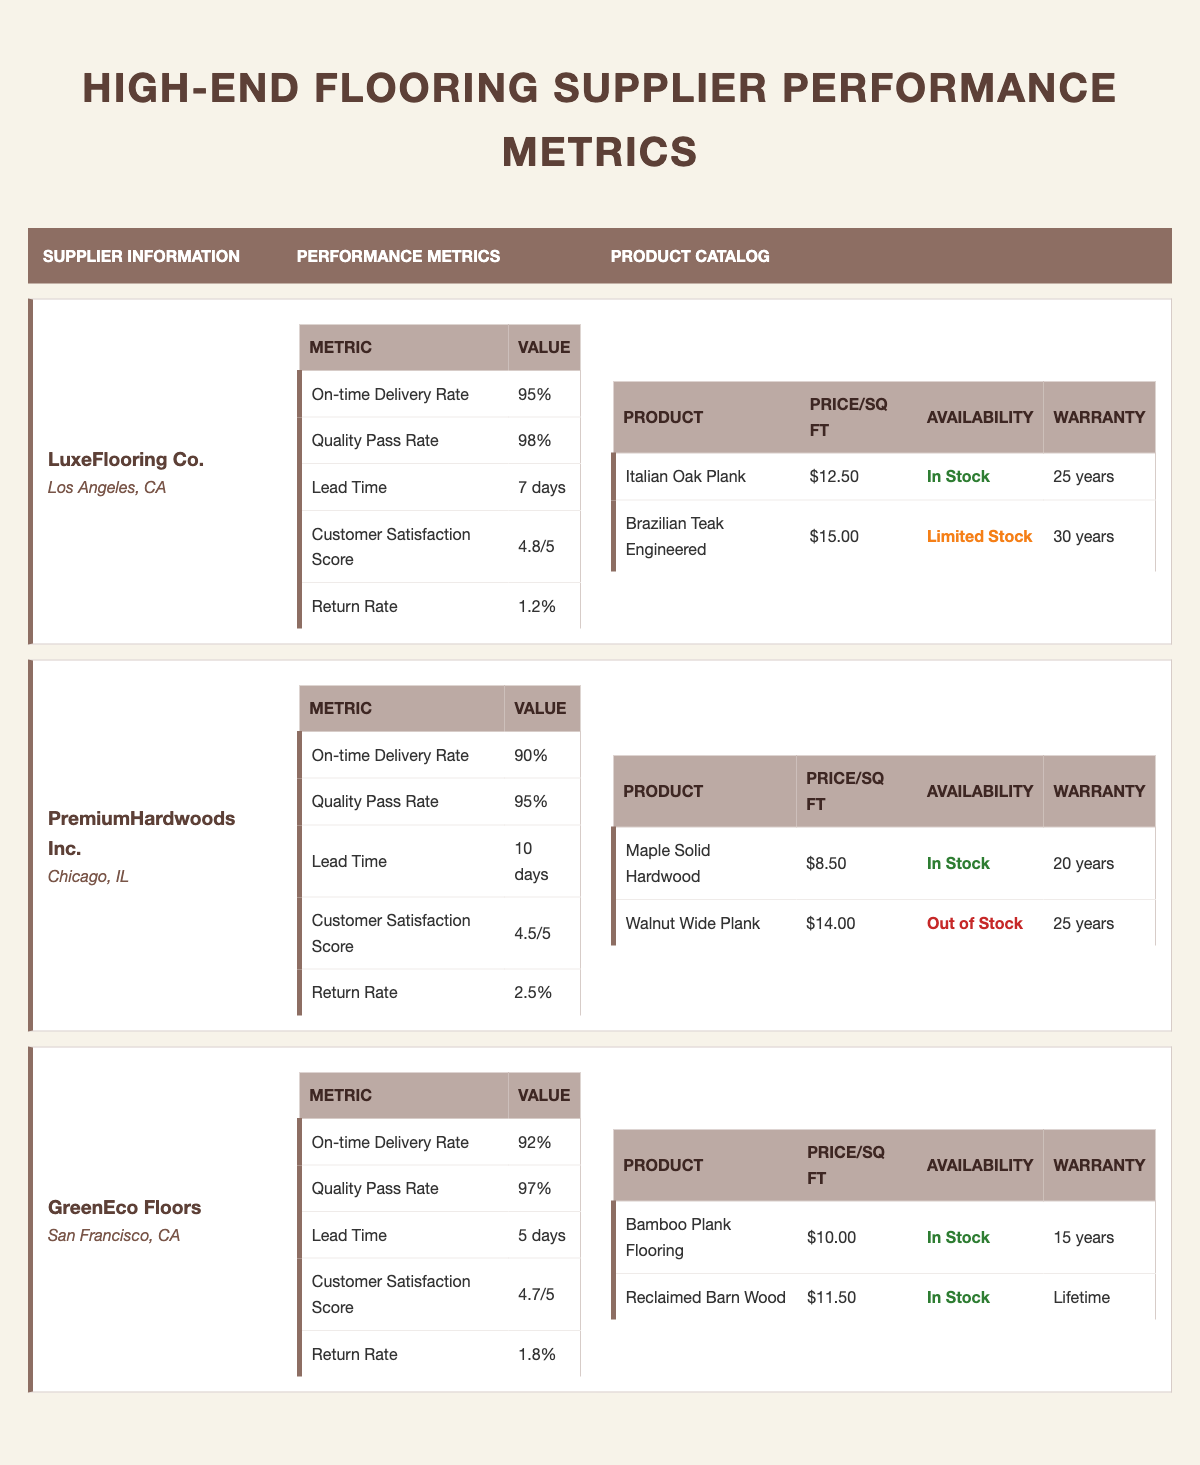What is the highest on-time delivery rate among the suppliers? The on-time delivery rates for each supplier are as follows: LuxeFlooring Co. has 95%, PremiumHardwoods Inc. has 90%, and GreenEco Floors has 92%. The highest of these is LuxeFlooring Co. at 95%.
Answer: 95% What is the average customer satisfaction score across all suppliers? The customer satisfaction scores are: LuxeFlooring Co. 4.8, PremiumHardwoods Inc. 4.5, and GreenEco Floors 4.7. To find the average, sum these scores: 4.8 + 4.5 + 4.7 = 14.0, and then divide by 3, which equals 4.67.
Answer: 4.67 Is the Brazilian Teak Engineered product in stock? According to the table, Brazil Teak Engineered is listed as "Limited Stock," which indicates that it is not currently fully available but may still be purchased.
Answer: No Which supplier has the shortest lead time? The lead times for each supplier are LuxeFlooring Co. with 7 days, PremiumHardwoods Inc. with 10 days, and GreenEco Floors with 5 days. The shortest lead time is from GreenEco Floors at 5 days.
Answer: 5 days What is the price difference between the Italian Oak Plank and Maple Solid Hardwood products? The price of Italian Oak Plank is $12.50 per square foot and Maple Solid Hardwood is $8.50 per square foot. To find the price difference, subtract the cost of Maple Solid from Italian Oak: $12.50 - $8.50 = $4.00.
Answer: $4.00 Which supplier has the highest return rate? The return rates are LuxeFlooring Co. at 1.2%, PremiumHardwoods Inc. at 2.5%, and GreenEco Floors at 1.8%. The highest return rate is PremiumHardwoods Inc. at 2.5%.
Answer: 2.5% What products are available in stock from GreenEco Floors? GreenEco Floors has two products: Bamboo Plank Flooring listed as "In Stock" and Reclaimed Barn Wood also listed as "In Stock." Both products are currently available.
Answer: Both products Is there any product with a warranty period longer than 30 years among the suppliers? The warranty periods are as follows: Brazilian Teak Engineered (30 years), Maple Solid Hardwood (20 years), Walnut Wide Plank (25 years), Bamboo Plank Flooring (15 years), and Reclaimed Barn Wood (Lifetime). The Reclaimed Barn Wood has a lifetime warranty, which is longer than 30 years.
Answer: Yes What percentage of quality pass rate does PremiumHardwoods Inc. have compared to LuxeFlooring Co.? LuxeFlooring Co. has a quality pass rate of 98%, while PremiumHardwoods Inc. has a rate of 95%. To compare, they can be expressed as a percentage: (95/98) * 100 = 96.94%. Therefore, PremiumHardwoods Inc. has 96.94% of LuxeFlooring Co.'s quality pass rate.
Answer: 96.94% 